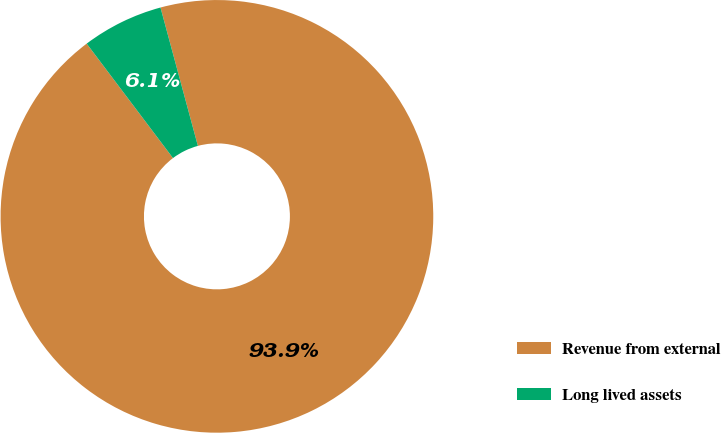Convert chart. <chart><loc_0><loc_0><loc_500><loc_500><pie_chart><fcel>Revenue from external<fcel>Long lived assets<nl><fcel>93.92%<fcel>6.08%<nl></chart> 